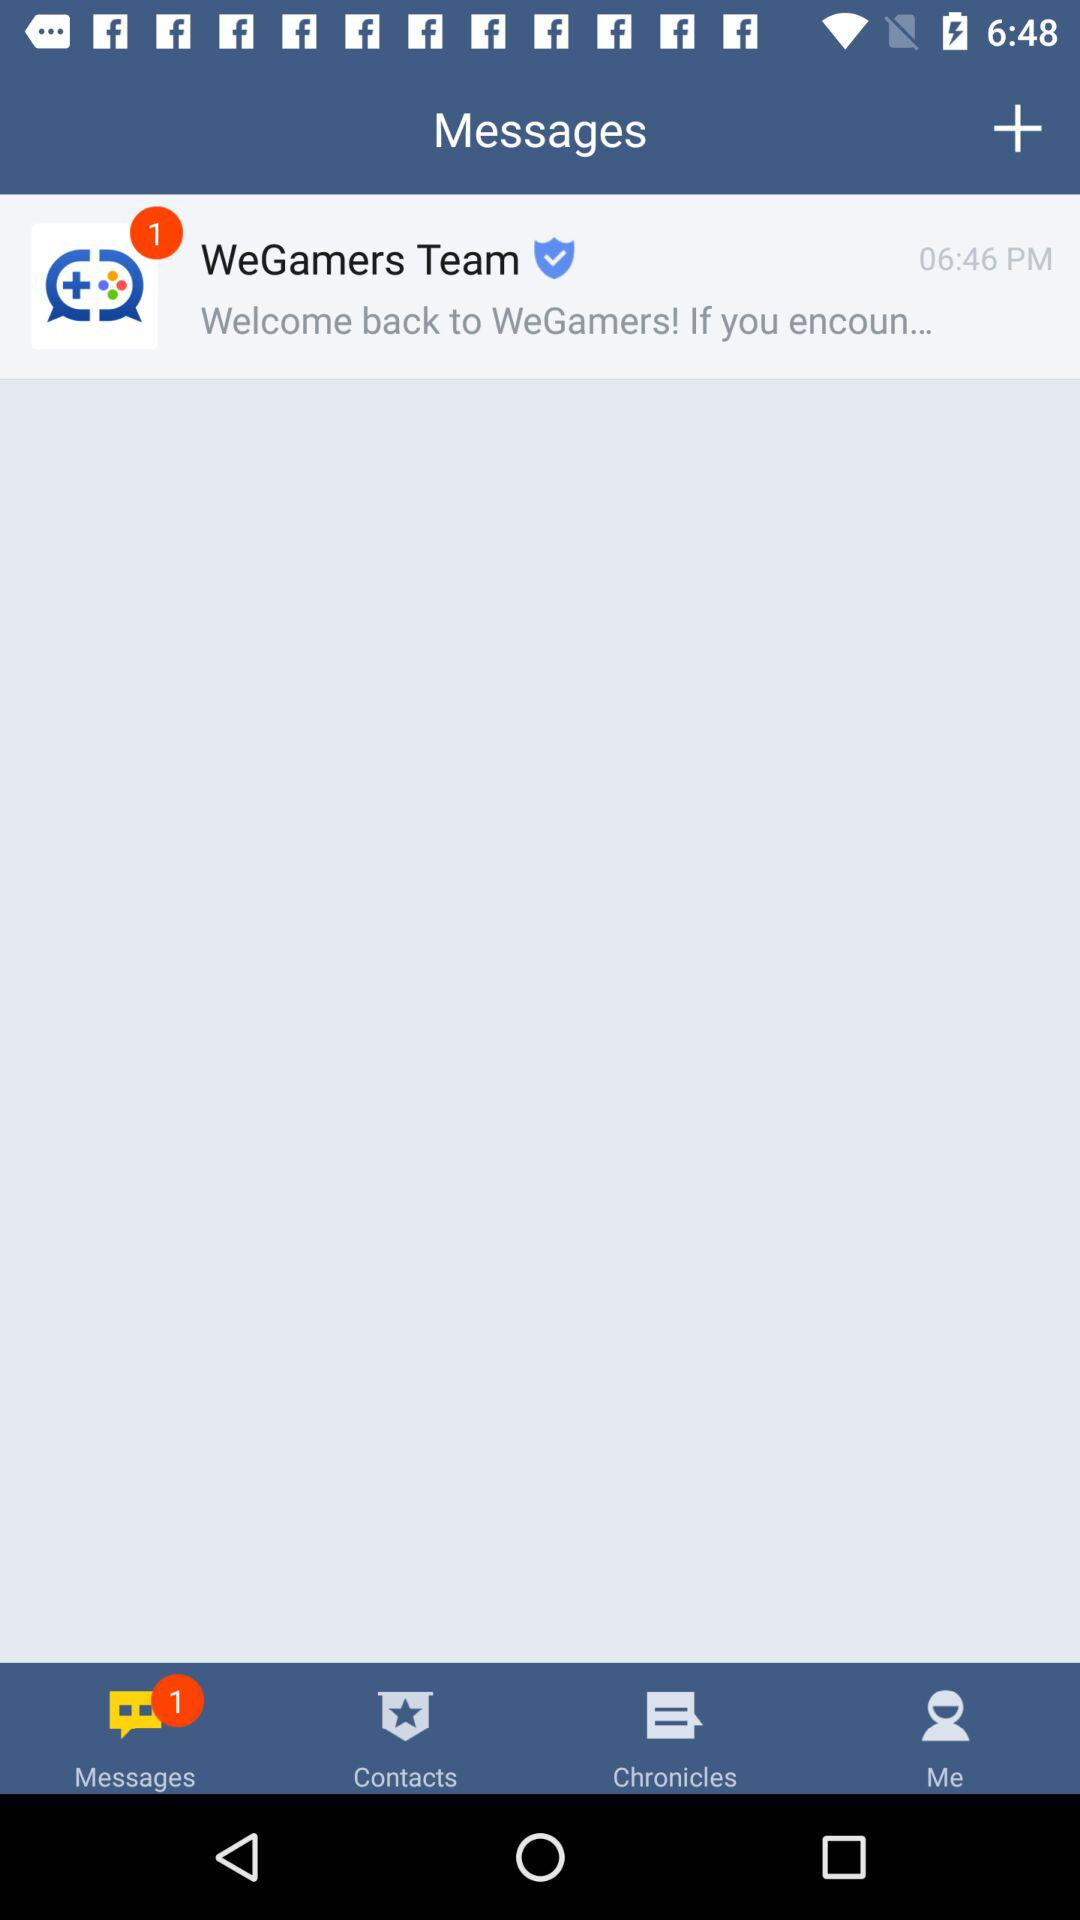What is the name of the team from which the message was received? The name of the team is "WeGamers Team". 